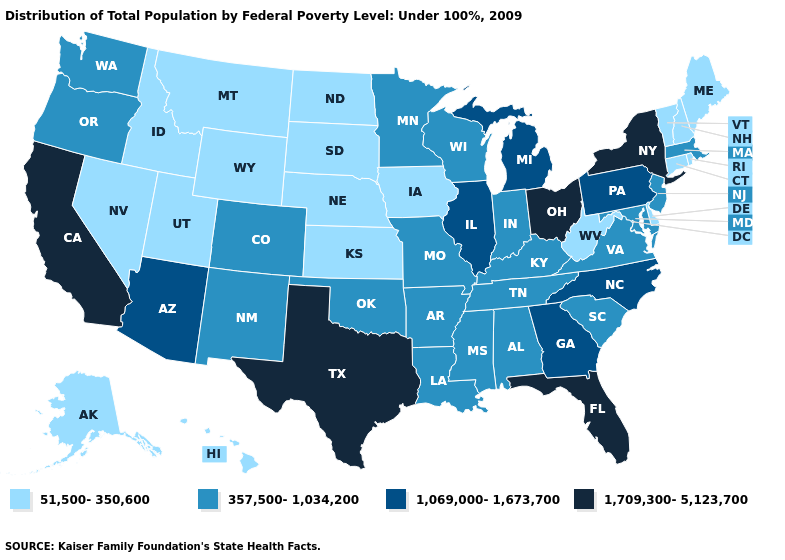Name the states that have a value in the range 51,500-350,600?
Answer briefly. Alaska, Connecticut, Delaware, Hawaii, Idaho, Iowa, Kansas, Maine, Montana, Nebraska, Nevada, New Hampshire, North Dakota, Rhode Island, South Dakota, Utah, Vermont, West Virginia, Wyoming. What is the value of Washington?
Be succinct. 357,500-1,034,200. What is the value of Montana?
Be succinct. 51,500-350,600. What is the value of Pennsylvania?
Be succinct. 1,069,000-1,673,700. What is the lowest value in states that border Utah?
Keep it brief. 51,500-350,600. What is the lowest value in the USA?
Write a very short answer. 51,500-350,600. Does Kansas have the highest value in the USA?
Keep it brief. No. Does the first symbol in the legend represent the smallest category?
Write a very short answer. Yes. Does New York have the highest value in the Northeast?
Concise answer only. Yes. Does New Jersey have the lowest value in the Northeast?
Keep it brief. No. Name the states that have a value in the range 1,709,300-5,123,700?
Short answer required. California, Florida, New York, Ohio, Texas. What is the highest value in states that border New Jersey?
Short answer required. 1,709,300-5,123,700. Does Hawaii have the highest value in the USA?
Give a very brief answer. No. Which states have the highest value in the USA?
Be succinct. California, Florida, New York, Ohio, Texas. 